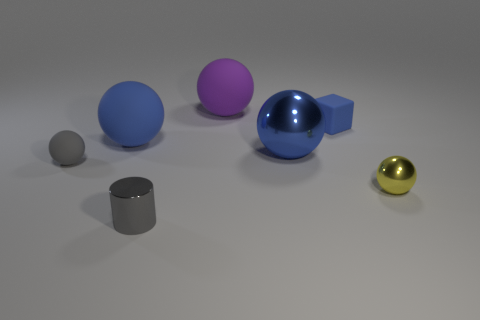Subtract all yellow spheres. How many spheres are left? 4 Subtract all big metal spheres. How many spheres are left? 4 Subtract all gray blocks. Subtract all cyan spheres. How many blocks are left? 1 Add 3 purple rubber balls. How many objects exist? 10 Subtract all spheres. How many objects are left? 2 Subtract all big cyan metallic things. Subtract all big rubber balls. How many objects are left? 5 Add 5 shiny cylinders. How many shiny cylinders are left? 6 Add 1 tiny things. How many tiny things exist? 5 Subtract 0 purple cubes. How many objects are left? 7 